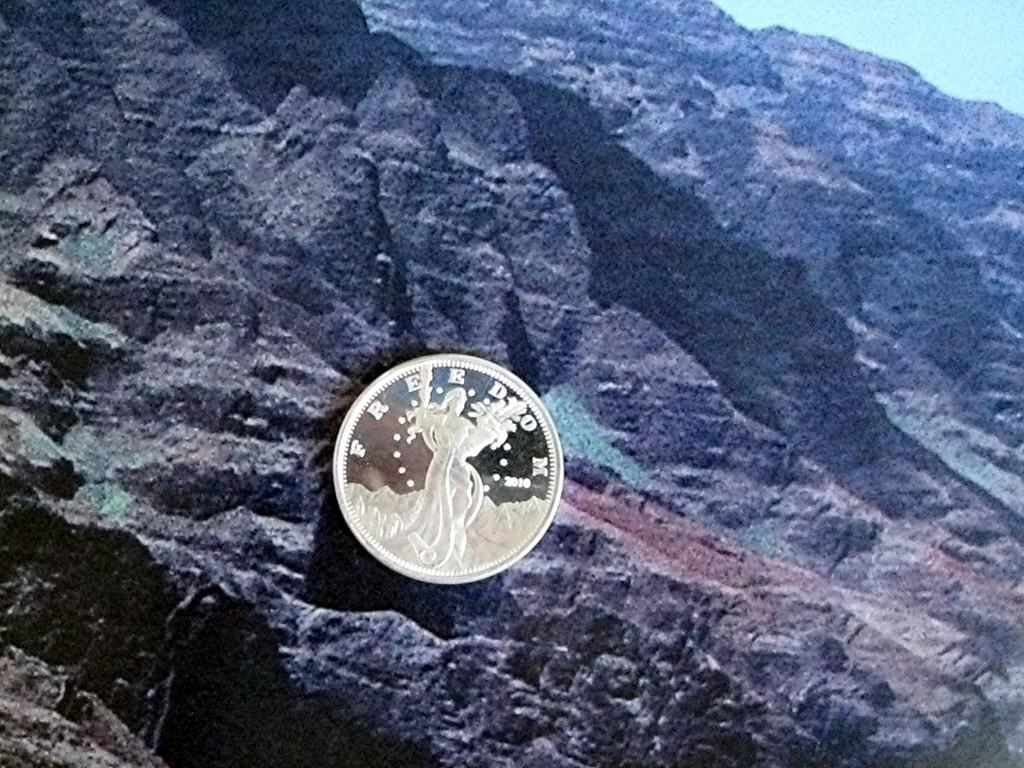<image>
Write a terse but informative summary of the picture. A silver coin with the word "FREEDOM" on it in front of some mountains. 